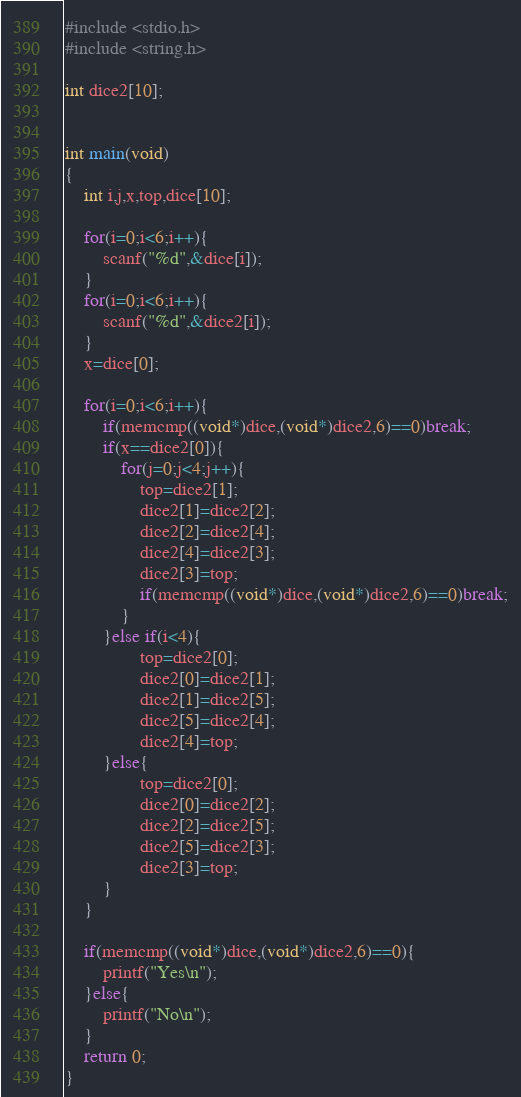Convert code to text. <code><loc_0><loc_0><loc_500><loc_500><_C_>#include <stdio.h>
#include <string.h>

int dice2[10];


int main(void)
{
    int i,j,x,top,dice[10];

    for(i=0;i<6;i++){
        scanf("%d",&dice[i]);
    }
    for(i=0;i<6;i++){
        scanf("%d",&dice2[i]);
    }
    x=dice[0];
    
    for(i=0;i<6;i++){
        if(memcmp((void*)dice,(void*)dice2,6)==0)break;
        if(x==dice2[0]){
            for(j=0;j<4;j++){
                top=dice2[1];
                dice2[1]=dice2[2];
                dice2[2]=dice2[4];
                dice2[4]=dice2[3];
                dice2[3]=top;
                if(memcmp((void*)dice,(void*)dice2,6)==0)break;
            }
        }else if(i<4){
                top=dice2[0];
                dice2[0]=dice2[1];
                dice2[1]=dice2[5];
                dice2[5]=dice2[4];
                dice2[4]=top;
        }else{
                top=dice2[0];
                dice2[0]=dice2[2];
                dice2[2]=dice2[5];
                dice2[5]=dice2[3];
                dice2[3]=top;
        }
    }

    if(memcmp((void*)dice,(void*)dice2,6)==0){
        printf("Yes\n");
    }else{
        printf("No\n");
    }
    return 0;
}

</code> 